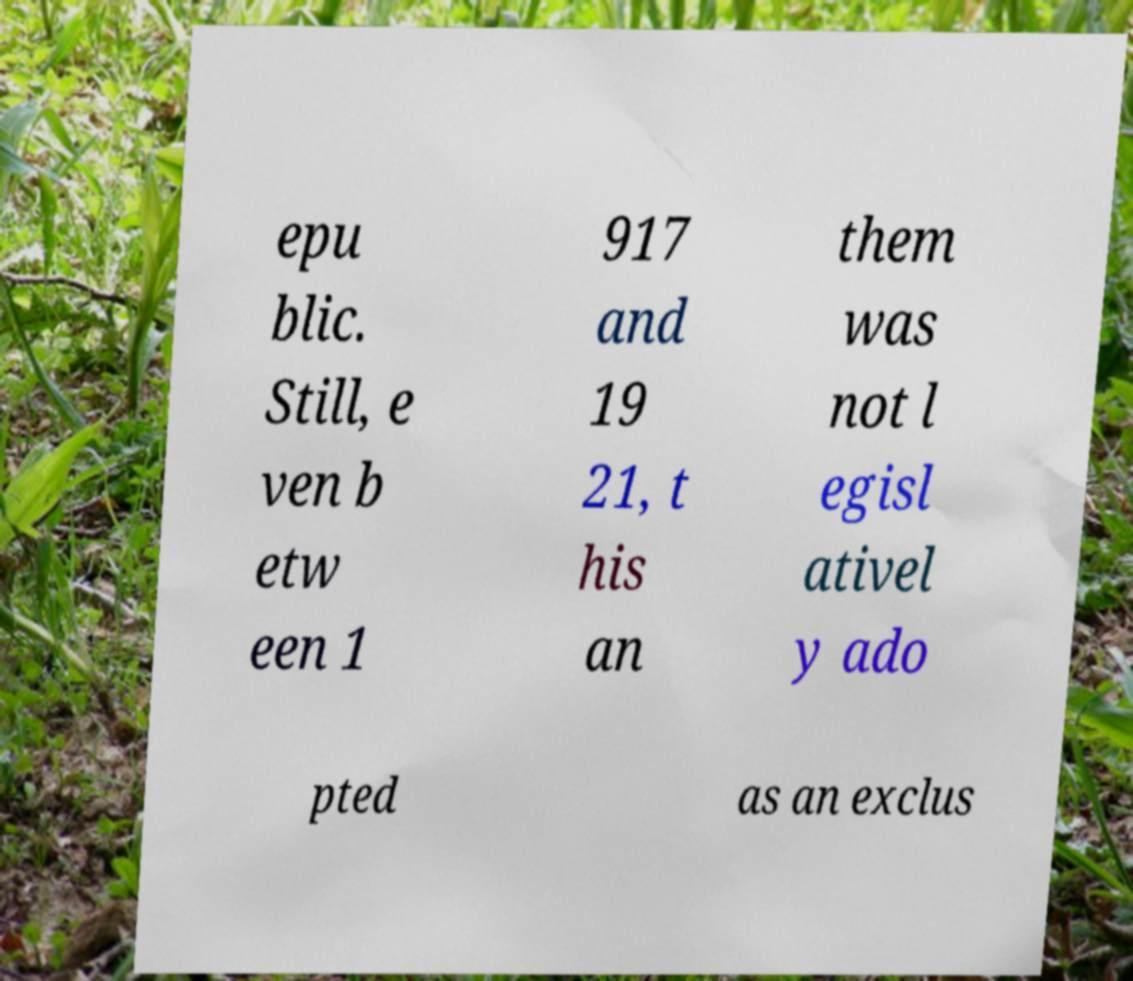For documentation purposes, I need the text within this image transcribed. Could you provide that? epu blic. Still, e ven b etw een 1 917 and 19 21, t his an them was not l egisl ativel y ado pted as an exclus 